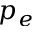Convert formula to latex. <formula><loc_0><loc_0><loc_500><loc_500>p _ { e }</formula> 